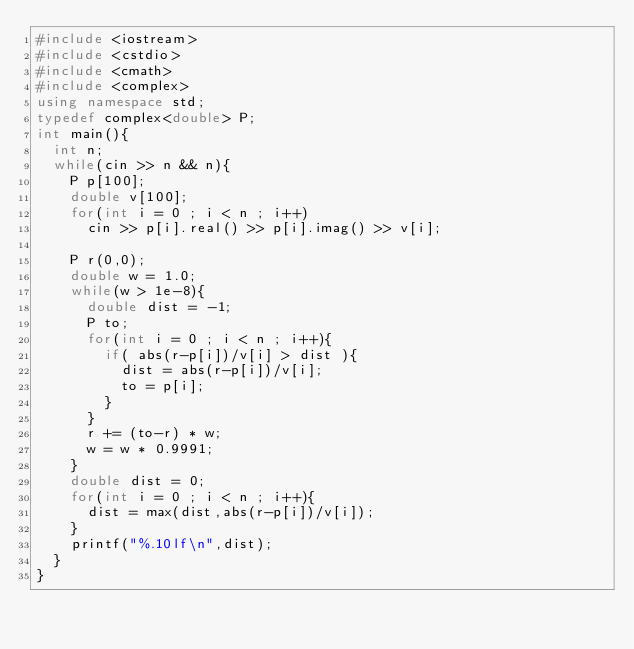<code> <loc_0><loc_0><loc_500><loc_500><_C++_>#include <iostream>
#include <cstdio>
#include <cmath>
#include <complex>
using namespace std;
typedef complex<double> P;
int main(){
	int n;
	while(cin >> n && n){
		P p[100];
		double v[100];
		for(int i = 0 ; i < n ; i++)
			cin >> p[i].real() >> p[i].imag() >> v[i];
		
		P r(0,0);
		double w = 1.0;
		while(w > 1e-8){
			double dist = -1;
			P to;
			for(int i = 0 ; i < n ; i++){
				if( abs(r-p[i])/v[i] > dist ){
					dist = abs(r-p[i])/v[i];
					to = p[i];
				}
			}
			r += (to-r) * w;
			w = w * 0.9991;
		}
		double dist = 0;
		for(int i = 0 ; i < n ; i++){
			dist = max(dist,abs(r-p[i])/v[i]);
		}
		printf("%.10lf\n",dist);
	}
}</code> 